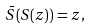<formula> <loc_0><loc_0><loc_500><loc_500>\bar { S } ( S ( z ) ) = z ,</formula> 